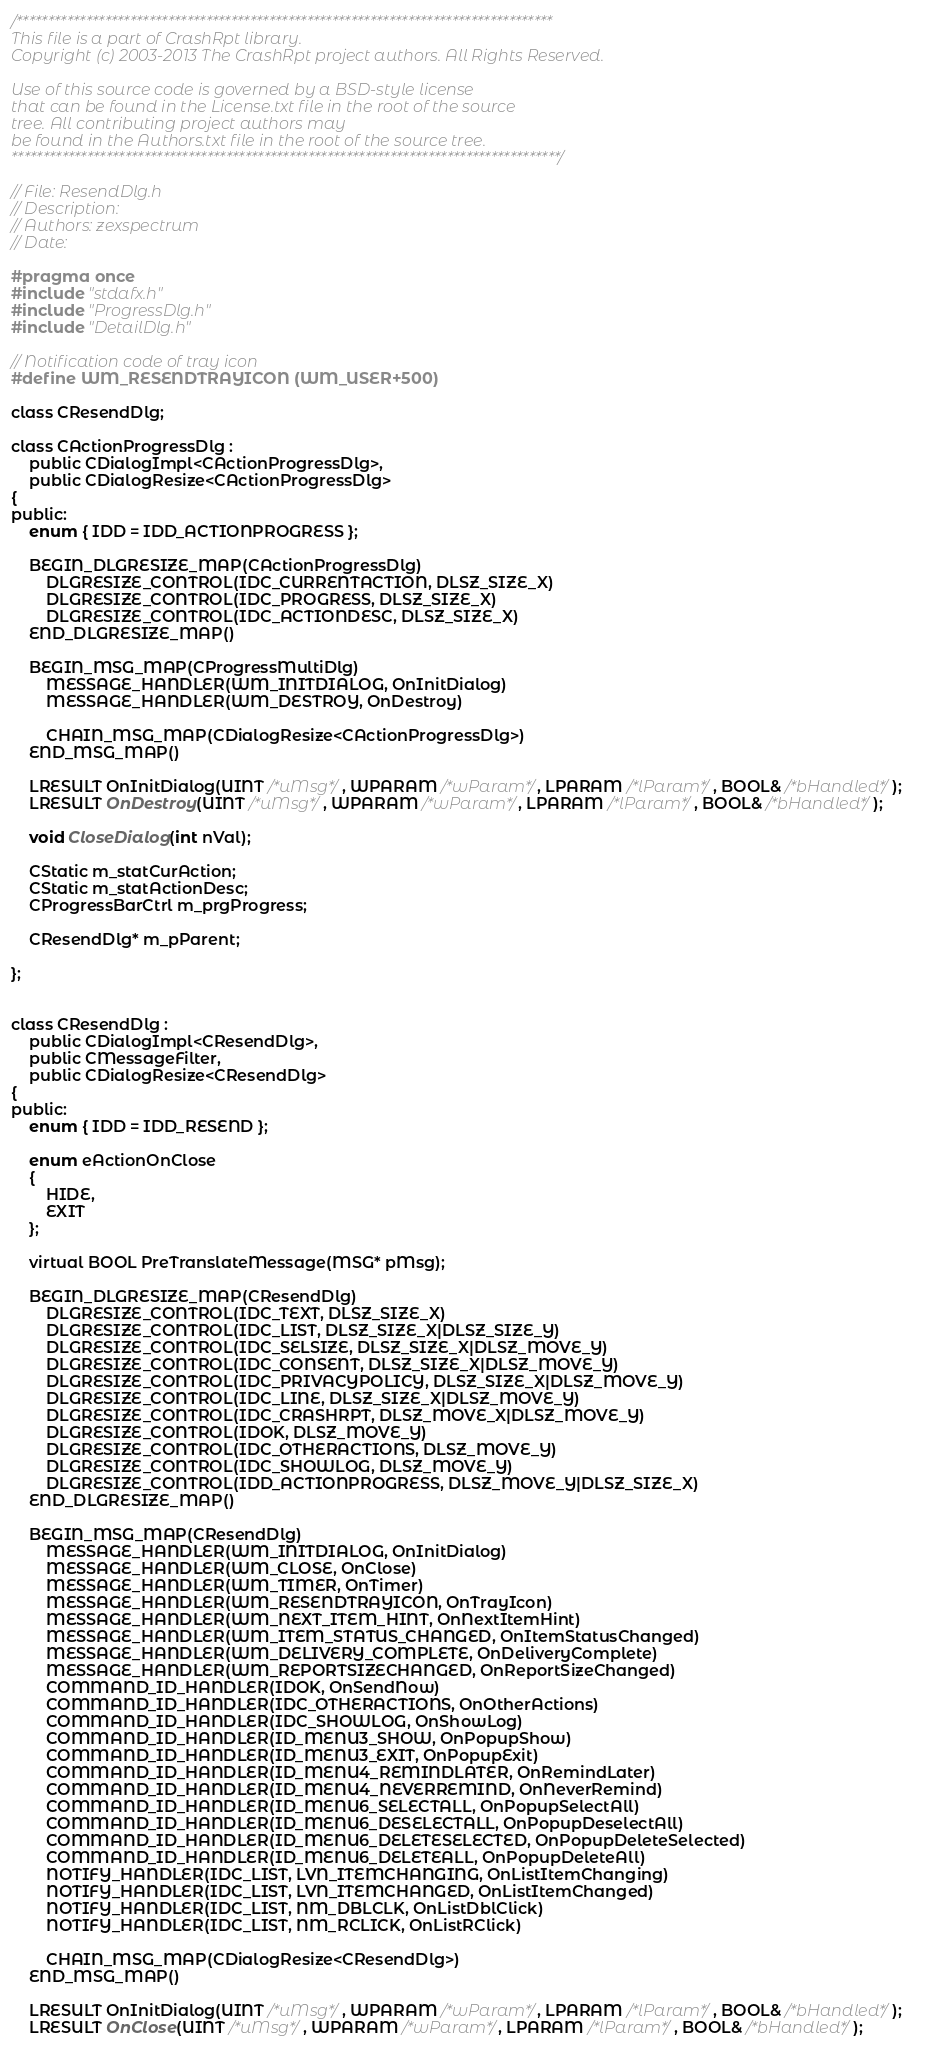Convert code to text. <code><loc_0><loc_0><loc_500><loc_500><_C_>/************************************************************************************* 
This file is a part of CrashRpt library.
Copyright (c) 2003-2013 The CrashRpt project authors. All Rights Reserved.

Use of this source code is governed by a BSD-style license
that can be found in the License.txt file in the root of the source
tree. All contributing project authors may
be found in the Authors.txt file in the root of the source tree.
***************************************************************************************/

// File: ResendDlg.h
// Description: 
// Authors: zexspectrum
// Date: 

#pragma once
#include "stdafx.h"
#include "ProgressDlg.h"
#include "DetailDlg.h"

// Notification code of tray icon
#define WM_RESENDTRAYICON (WM_USER+500)

class CResendDlg;

class CActionProgressDlg : 
    public CDialogImpl<CActionProgressDlg>,   	
    public CDialogResize<CActionProgressDlg>
{
public:
    enum { IDD = IDD_ACTIONPROGRESS };

    BEGIN_DLGRESIZE_MAP(CActionProgressDlg)    
        DLGRESIZE_CONTROL(IDC_CURRENTACTION, DLSZ_SIZE_X)    
        DLGRESIZE_CONTROL(IDC_PROGRESS, DLSZ_SIZE_X)    
        DLGRESIZE_CONTROL(IDC_ACTIONDESC, DLSZ_SIZE_X)        
    END_DLGRESIZE_MAP()

    BEGIN_MSG_MAP(CProgressMultiDlg)
        MESSAGE_HANDLER(WM_INITDIALOG, OnInitDialog)
        MESSAGE_HANDLER(WM_DESTROY, OnDestroy)

        CHAIN_MSG_MAP(CDialogResize<CActionProgressDlg>)
    END_MSG_MAP()

    LRESULT OnInitDialog(UINT /*uMsg*/, WPARAM /*wParam*/, LPARAM /*lParam*/, BOOL& /*bHandled*/);      
    LRESULT OnDestroy(UINT /*uMsg*/, WPARAM /*wParam*/, LPARAM /*lParam*/, BOOL& /*bHandled*/);	    

    void CloseDialog(int nVal);

    CStatic m_statCurAction;
    CStatic m_statActionDesc;
    CProgressBarCtrl m_prgProgress;

    CResendDlg* m_pParent;

};


class CResendDlg : 
    public CDialogImpl<CResendDlg>,   
    public CMessageFilter,
    public CDialogResize<CResendDlg>
{
public:
    enum { IDD = IDD_RESEND };

	enum eActionOnClose 
	{
		HIDE, 
		EXIT
	};

    virtual BOOL PreTranslateMessage(MSG* pMsg);

    BEGIN_DLGRESIZE_MAP(CResendDlg)    
        DLGRESIZE_CONTROL(IDC_TEXT, DLSZ_SIZE_X)    
        DLGRESIZE_CONTROL(IDC_LIST, DLSZ_SIZE_X|DLSZ_SIZE_Y)    
        DLGRESIZE_CONTROL(IDC_SELSIZE, DLSZ_SIZE_X|DLSZ_MOVE_Y)    
        DLGRESIZE_CONTROL(IDC_CONSENT, DLSZ_SIZE_X|DLSZ_MOVE_Y)    
        DLGRESIZE_CONTROL(IDC_PRIVACYPOLICY, DLSZ_SIZE_X|DLSZ_MOVE_Y)    
        DLGRESIZE_CONTROL(IDC_LINE, DLSZ_SIZE_X|DLSZ_MOVE_Y)    
        DLGRESIZE_CONTROL(IDC_CRASHRPT, DLSZ_MOVE_X|DLSZ_MOVE_Y)    
        DLGRESIZE_CONTROL(IDOK, DLSZ_MOVE_Y)    
        DLGRESIZE_CONTROL(IDC_OTHERACTIONS, DLSZ_MOVE_Y)    
        DLGRESIZE_CONTROL(IDC_SHOWLOG, DLSZ_MOVE_Y)    
        DLGRESIZE_CONTROL(IDD_ACTIONPROGRESS, DLSZ_MOVE_Y|DLSZ_SIZE_X)    
    END_DLGRESIZE_MAP()

    BEGIN_MSG_MAP(CResendDlg)
        MESSAGE_HANDLER(WM_INITDIALOG, OnInitDialog)
        MESSAGE_HANDLER(WM_CLOSE, OnClose)
        MESSAGE_HANDLER(WM_TIMER, OnTimer)
        MESSAGE_HANDLER(WM_RESENDTRAYICON, OnTrayIcon)    
		MESSAGE_HANDLER(WM_NEXT_ITEM_HINT, OnNextItemHint)    
		MESSAGE_HANDLER(WM_ITEM_STATUS_CHANGED, OnItemStatusChanged)    
		MESSAGE_HANDLER(WM_DELIVERY_COMPLETE, OnDeliveryComplete)   
		MESSAGE_HANDLER(WM_REPORTSIZECHANGED, OnReportSizeChanged)
        COMMAND_ID_HANDLER(IDOK, OnSendNow)
        COMMAND_ID_HANDLER(IDC_OTHERACTIONS, OnOtherActions)
        COMMAND_ID_HANDLER(IDC_SHOWLOG, OnShowLog)
        COMMAND_ID_HANDLER(ID_MENU3_SHOW, OnPopupShow)
        COMMAND_ID_HANDLER(ID_MENU3_EXIT, OnPopupExit)
        COMMAND_ID_HANDLER(ID_MENU4_REMINDLATER, OnRemindLater)
        COMMAND_ID_HANDLER(ID_MENU4_NEVERREMIND, OnNeverRemind)
		COMMAND_ID_HANDLER(ID_MENU6_SELECTALL, OnPopupSelectAll)
		COMMAND_ID_HANDLER(ID_MENU6_DESELECTALL, OnPopupDeselectAll)
		COMMAND_ID_HANDLER(ID_MENU6_DELETESELECTED, OnPopupDeleteSelected)
		COMMAND_ID_HANDLER(ID_MENU6_DELETEALL, OnPopupDeleteAll)
        NOTIFY_HANDLER(IDC_LIST, LVN_ITEMCHANGING, OnListItemChanging)
        NOTIFY_HANDLER(IDC_LIST, LVN_ITEMCHANGED, OnListItemChanged)
        NOTIFY_HANDLER(IDC_LIST, NM_DBLCLK, OnListDblClick)
		NOTIFY_HANDLER(IDC_LIST, NM_RCLICK, OnListRClick)

        CHAIN_MSG_MAP(CDialogResize<CResendDlg>)
    END_MSG_MAP()

    LRESULT OnInitDialog(UINT /*uMsg*/, WPARAM /*wParam*/, LPARAM /*lParam*/, BOOL& /*bHandled*/);  
    LRESULT OnClose(UINT /*uMsg*/, WPARAM /*wParam*/, LPARAM /*lParam*/, BOOL& /*bHandled*/);	    </code> 